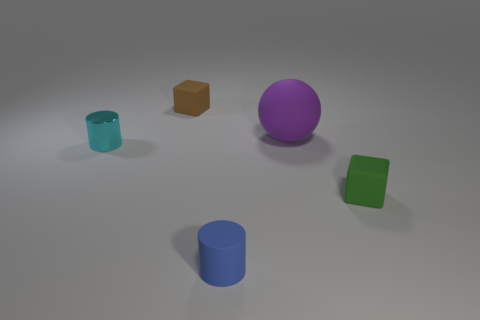Add 3 green rubber cubes. How many objects exist? 8 Subtract 1 cylinders. How many cylinders are left? 1 Subtract 0 green cylinders. How many objects are left? 5 Subtract all spheres. How many objects are left? 4 Subtract all yellow balls. Subtract all cyan cylinders. How many balls are left? 1 Subtract all tiny gray shiny blocks. Subtract all large purple rubber balls. How many objects are left? 4 Add 3 small blue cylinders. How many small blue cylinders are left? 4 Add 1 tiny gray rubber cubes. How many tiny gray rubber cubes exist? 1 